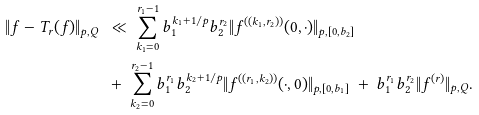<formula> <loc_0><loc_0><loc_500><loc_500>\| f - T _ { r } ( f ) \| _ { p , Q } \ & \ll \ \sum _ { k _ { 1 } = 0 } ^ { r _ { 1 } - 1 } b _ { 1 } ^ { k _ { 1 } + 1 / p } b _ { 2 } ^ { r _ { 2 } } \| f ^ { ( ( k _ { 1 } , r _ { 2 } ) ) } ( 0 , \cdot ) \| _ { p , [ 0 , b _ { 2 } ] } \\ \ & + \ \sum _ { k _ { 2 } = 0 } ^ { r _ { 2 } - 1 } b _ { 1 } ^ { r _ { 1 } } b _ { 2 } ^ { k _ { 2 } + 1 / p } \| f ^ { ( ( r _ { 1 } , k _ { 2 } ) ) } ( \cdot , 0 ) \| _ { p , [ 0 , b _ { 1 } ] } \ + \ b _ { 1 } ^ { r _ { 1 } } b _ { 2 } ^ { r _ { 2 } } \| f ^ { ( r ) } \| _ { p , Q } .</formula> 